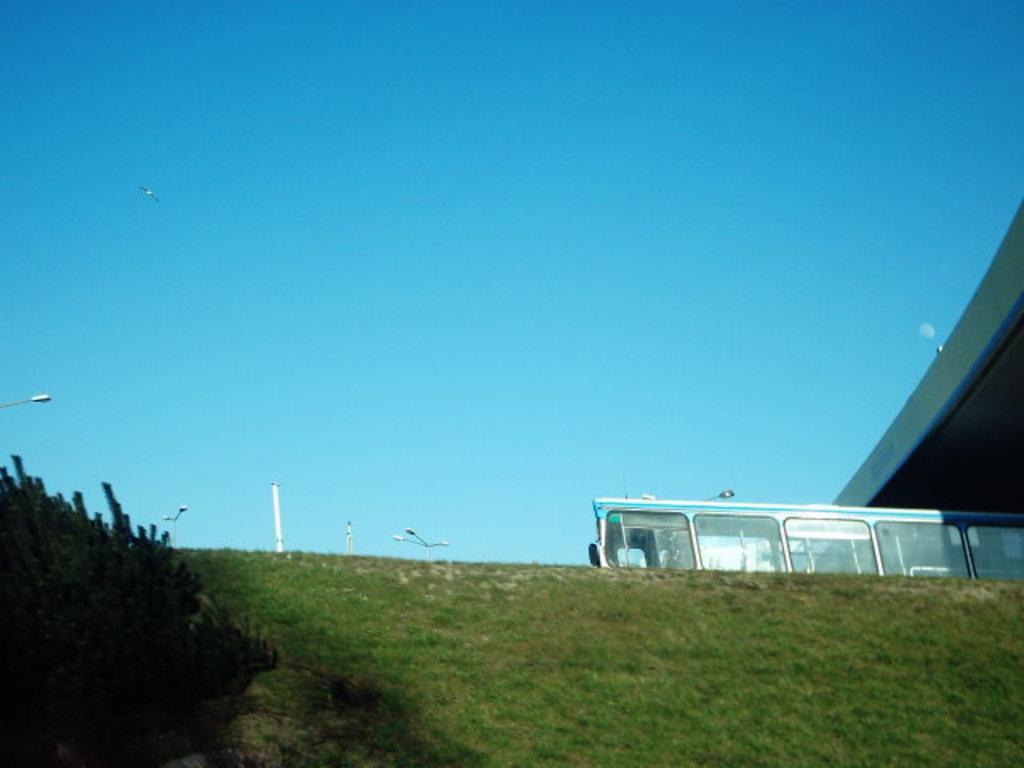How would you summarize this image in a sentence or two? In this picture we can observe grass on the ground. On the left side there are some plants. We can observe a vehicle here. In the background there is a sky which is in blue color. 